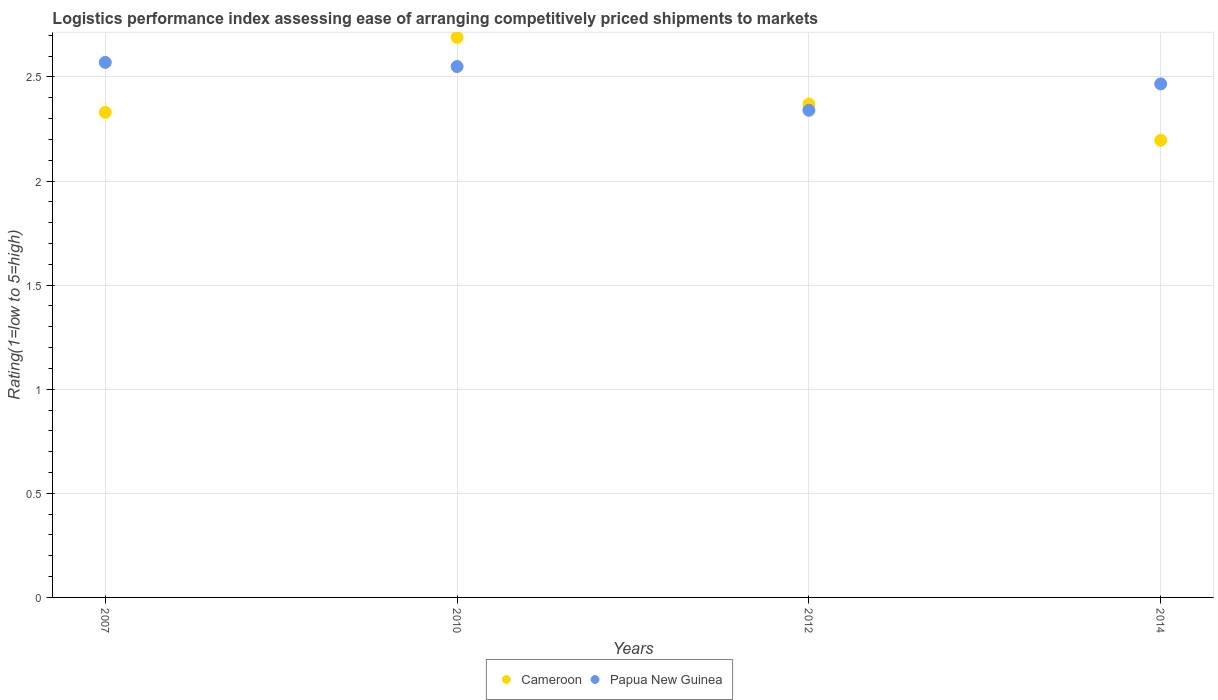How many different coloured dotlines are there?
Offer a very short reply. 2. What is the Logistic performance index in Cameroon in 2007?
Offer a very short reply. 2.33. Across all years, what is the maximum Logistic performance index in Papua New Guinea?
Offer a terse response. 2.57. Across all years, what is the minimum Logistic performance index in Cameroon?
Ensure brevity in your answer.  2.2. In which year was the Logistic performance index in Cameroon minimum?
Ensure brevity in your answer.  2014. What is the total Logistic performance index in Cameroon in the graph?
Ensure brevity in your answer.  9.59. What is the difference between the Logistic performance index in Cameroon in 2012 and that in 2014?
Give a very brief answer. 0.17. What is the difference between the Logistic performance index in Cameroon in 2010 and the Logistic performance index in Papua New Guinea in 2012?
Offer a terse response. 0.35. What is the average Logistic performance index in Papua New Guinea per year?
Your answer should be very brief. 2.48. In the year 2010, what is the difference between the Logistic performance index in Papua New Guinea and Logistic performance index in Cameroon?
Provide a short and direct response. -0.14. What is the ratio of the Logistic performance index in Cameroon in 2010 to that in 2014?
Make the answer very short. 1.23. What is the difference between the highest and the second highest Logistic performance index in Papua New Guinea?
Offer a terse response. 0.02. What is the difference between the highest and the lowest Logistic performance index in Papua New Guinea?
Ensure brevity in your answer.  0.23. Is the sum of the Logistic performance index in Papua New Guinea in 2007 and 2012 greater than the maximum Logistic performance index in Cameroon across all years?
Your answer should be very brief. Yes. Is the Logistic performance index in Cameroon strictly greater than the Logistic performance index in Papua New Guinea over the years?
Make the answer very short. No. What is the difference between two consecutive major ticks on the Y-axis?
Ensure brevity in your answer.  0.5. Are the values on the major ticks of Y-axis written in scientific E-notation?
Your answer should be compact. No. Does the graph contain any zero values?
Your answer should be very brief. No. How are the legend labels stacked?
Your answer should be very brief. Horizontal. What is the title of the graph?
Ensure brevity in your answer.  Logistics performance index assessing ease of arranging competitively priced shipments to markets. Does "American Samoa" appear as one of the legend labels in the graph?
Ensure brevity in your answer.  No. What is the label or title of the X-axis?
Your answer should be compact. Years. What is the label or title of the Y-axis?
Your answer should be compact. Rating(1=low to 5=high). What is the Rating(1=low to 5=high) of Cameroon in 2007?
Your answer should be compact. 2.33. What is the Rating(1=low to 5=high) in Papua New Guinea in 2007?
Offer a terse response. 2.57. What is the Rating(1=low to 5=high) in Cameroon in 2010?
Provide a succinct answer. 2.69. What is the Rating(1=low to 5=high) in Papua New Guinea in 2010?
Ensure brevity in your answer.  2.55. What is the Rating(1=low to 5=high) in Cameroon in 2012?
Ensure brevity in your answer.  2.37. What is the Rating(1=low to 5=high) of Papua New Guinea in 2012?
Give a very brief answer. 2.34. What is the Rating(1=low to 5=high) in Cameroon in 2014?
Ensure brevity in your answer.  2.2. What is the Rating(1=low to 5=high) of Papua New Guinea in 2014?
Your response must be concise. 2.47. Across all years, what is the maximum Rating(1=low to 5=high) of Cameroon?
Provide a succinct answer. 2.69. Across all years, what is the maximum Rating(1=low to 5=high) in Papua New Guinea?
Keep it short and to the point. 2.57. Across all years, what is the minimum Rating(1=low to 5=high) of Cameroon?
Your response must be concise. 2.2. Across all years, what is the minimum Rating(1=low to 5=high) in Papua New Guinea?
Give a very brief answer. 2.34. What is the total Rating(1=low to 5=high) of Cameroon in the graph?
Make the answer very short. 9.59. What is the total Rating(1=low to 5=high) of Papua New Guinea in the graph?
Your response must be concise. 9.93. What is the difference between the Rating(1=low to 5=high) in Cameroon in 2007 and that in 2010?
Offer a terse response. -0.36. What is the difference between the Rating(1=low to 5=high) of Papua New Guinea in 2007 and that in 2010?
Make the answer very short. 0.02. What is the difference between the Rating(1=low to 5=high) of Cameroon in 2007 and that in 2012?
Offer a terse response. -0.04. What is the difference between the Rating(1=low to 5=high) of Papua New Guinea in 2007 and that in 2012?
Offer a terse response. 0.23. What is the difference between the Rating(1=low to 5=high) of Cameroon in 2007 and that in 2014?
Offer a terse response. 0.13. What is the difference between the Rating(1=low to 5=high) of Papua New Guinea in 2007 and that in 2014?
Your response must be concise. 0.1. What is the difference between the Rating(1=low to 5=high) in Cameroon in 2010 and that in 2012?
Your answer should be compact. 0.32. What is the difference between the Rating(1=low to 5=high) of Papua New Guinea in 2010 and that in 2012?
Provide a succinct answer. 0.21. What is the difference between the Rating(1=low to 5=high) of Cameroon in 2010 and that in 2014?
Ensure brevity in your answer.  0.49. What is the difference between the Rating(1=low to 5=high) of Papua New Guinea in 2010 and that in 2014?
Ensure brevity in your answer.  0.08. What is the difference between the Rating(1=low to 5=high) in Cameroon in 2012 and that in 2014?
Give a very brief answer. 0.17. What is the difference between the Rating(1=low to 5=high) in Papua New Guinea in 2012 and that in 2014?
Ensure brevity in your answer.  -0.13. What is the difference between the Rating(1=low to 5=high) in Cameroon in 2007 and the Rating(1=low to 5=high) in Papua New Guinea in 2010?
Offer a terse response. -0.22. What is the difference between the Rating(1=low to 5=high) in Cameroon in 2007 and the Rating(1=low to 5=high) in Papua New Guinea in 2012?
Offer a terse response. -0.01. What is the difference between the Rating(1=low to 5=high) of Cameroon in 2007 and the Rating(1=low to 5=high) of Papua New Guinea in 2014?
Your answer should be very brief. -0.14. What is the difference between the Rating(1=low to 5=high) of Cameroon in 2010 and the Rating(1=low to 5=high) of Papua New Guinea in 2014?
Offer a very short reply. 0.22. What is the difference between the Rating(1=low to 5=high) in Cameroon in 2012 and the Rating(1=low to 5=high) in Papua New Guinea in 2014?
Give a very brief answer. -0.1. What is the average Rating(1=low to 5=high) of Cameroon per year?
Provide a short and direct response. 2.4. What is the average Rating(1=low to 5=high) of Papua New Guinea per year?
Make the answer very short. 2.48. In the year 2007, what is the difference between the Rating(1=low to 5=high) of Cameroon and Rating(1=low to 5=high) of Papua New Guinea?
Provide a short and direct response. -0.24. In the year 2010, what is the difference between the Rating(1=low to 5=high) of Cameroon and Rating(1=low to 5=high) of Papua New Guinea?
Keep it short and to the point. 0.14. In the year 2012, what is the difference between the Rating(1=low to 5=high) of Cameroon and Rating(1=low to 5=high) of Papua New Guinea?
Keep it short and to the point. 0.03. In the year 2014, what is the difference between the Rating(1=low to 5=high) in Cameroon and Rating(1=low to 5=high) in Papua New Guinea?
Ensure brevity in your answer.  -0.27. What is the ratio of the Rating(1=low to 5=high) in Cameroon in 2007 to that in 2010?
Provide a short and direct response. 0.87. What is the ratio of the Rating(1=low to 5=high) of Cameroon in 2007 to that in 2012?
Provide a succinct answer. 0.98. What is the ratio of the Rating(1=low to 5=high) in Papua New Guinea in 2007 to that in 2012?
Give a very brief answer. 1.1. What is the ratio of the Rating(1=low to 5=high) of Cameroon in 2007 to that in 2014?
Your response must be concise. 1.06. What is the ratio of the Rating(1=low to 5=high) in Papua New Guinea in 2007 to that in 2014?
Your answer should be compact. 1.04. What is the ratio of the Rating(1=low to 5=high) in Cameroon in 2010 to that in 2012?
Your response must be concise. 1.14. What is the ratio of the Rating(1=low to 5=high) in Papua New Guinea in 2010 to that in 2012?
Offer a very short reply. 1.09. What is the ratio of the Rating(1=low to 5=high) in Cameroon in 2010 to that in 2014?
Give a very brief answer. 1.23. What is the ratio of the Rating(1=low to 5=high) of Papua New Guinea in 2010 to that in 2014?
Make the answer very short. 1.03. What is the ratio of the Rating(1=low to 5=high) in Cameroon in 2012 to that in 2014?
Offer a very short reply. 1.08. What is the ratio of the Rating(1=low to 5=high) in Papua New Guinea in 2012 to that in 2014?
Keep it short and to the point. 0.95. What is the difference between the highest and the second highest Rating(1=low to 5=high) in Cameroon?
Your answer should be very brief. 0.32. What is the difference between the highest and the second highest Rating(1=low to 5=high) of Papua New Guinea?
Provide a short and direct response. 0.02. What is the difference between the highest and the lowest Rating(1=low to 5=high) in Cameroon?
Your response must be concise. 0.49. What is the difference between the highest and the lowest Rating(1=low to 5=high) in Papua New Guinea?
Provide a succinct answer. 0.23. 